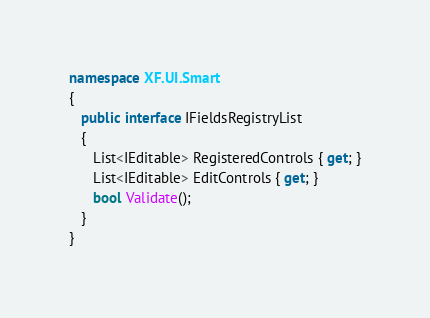Convert code to text. <code><loc_0><loc_0><loc_500><loc_500><_C#_>
namespace XF.UI.Smart
{
   public interface IFieldsRegistryList
   {
      List<IEditable> RegisteredControls { get; }
      List<IEditable> EditControls { get; }
      bool Validate();
   }
}</code> 